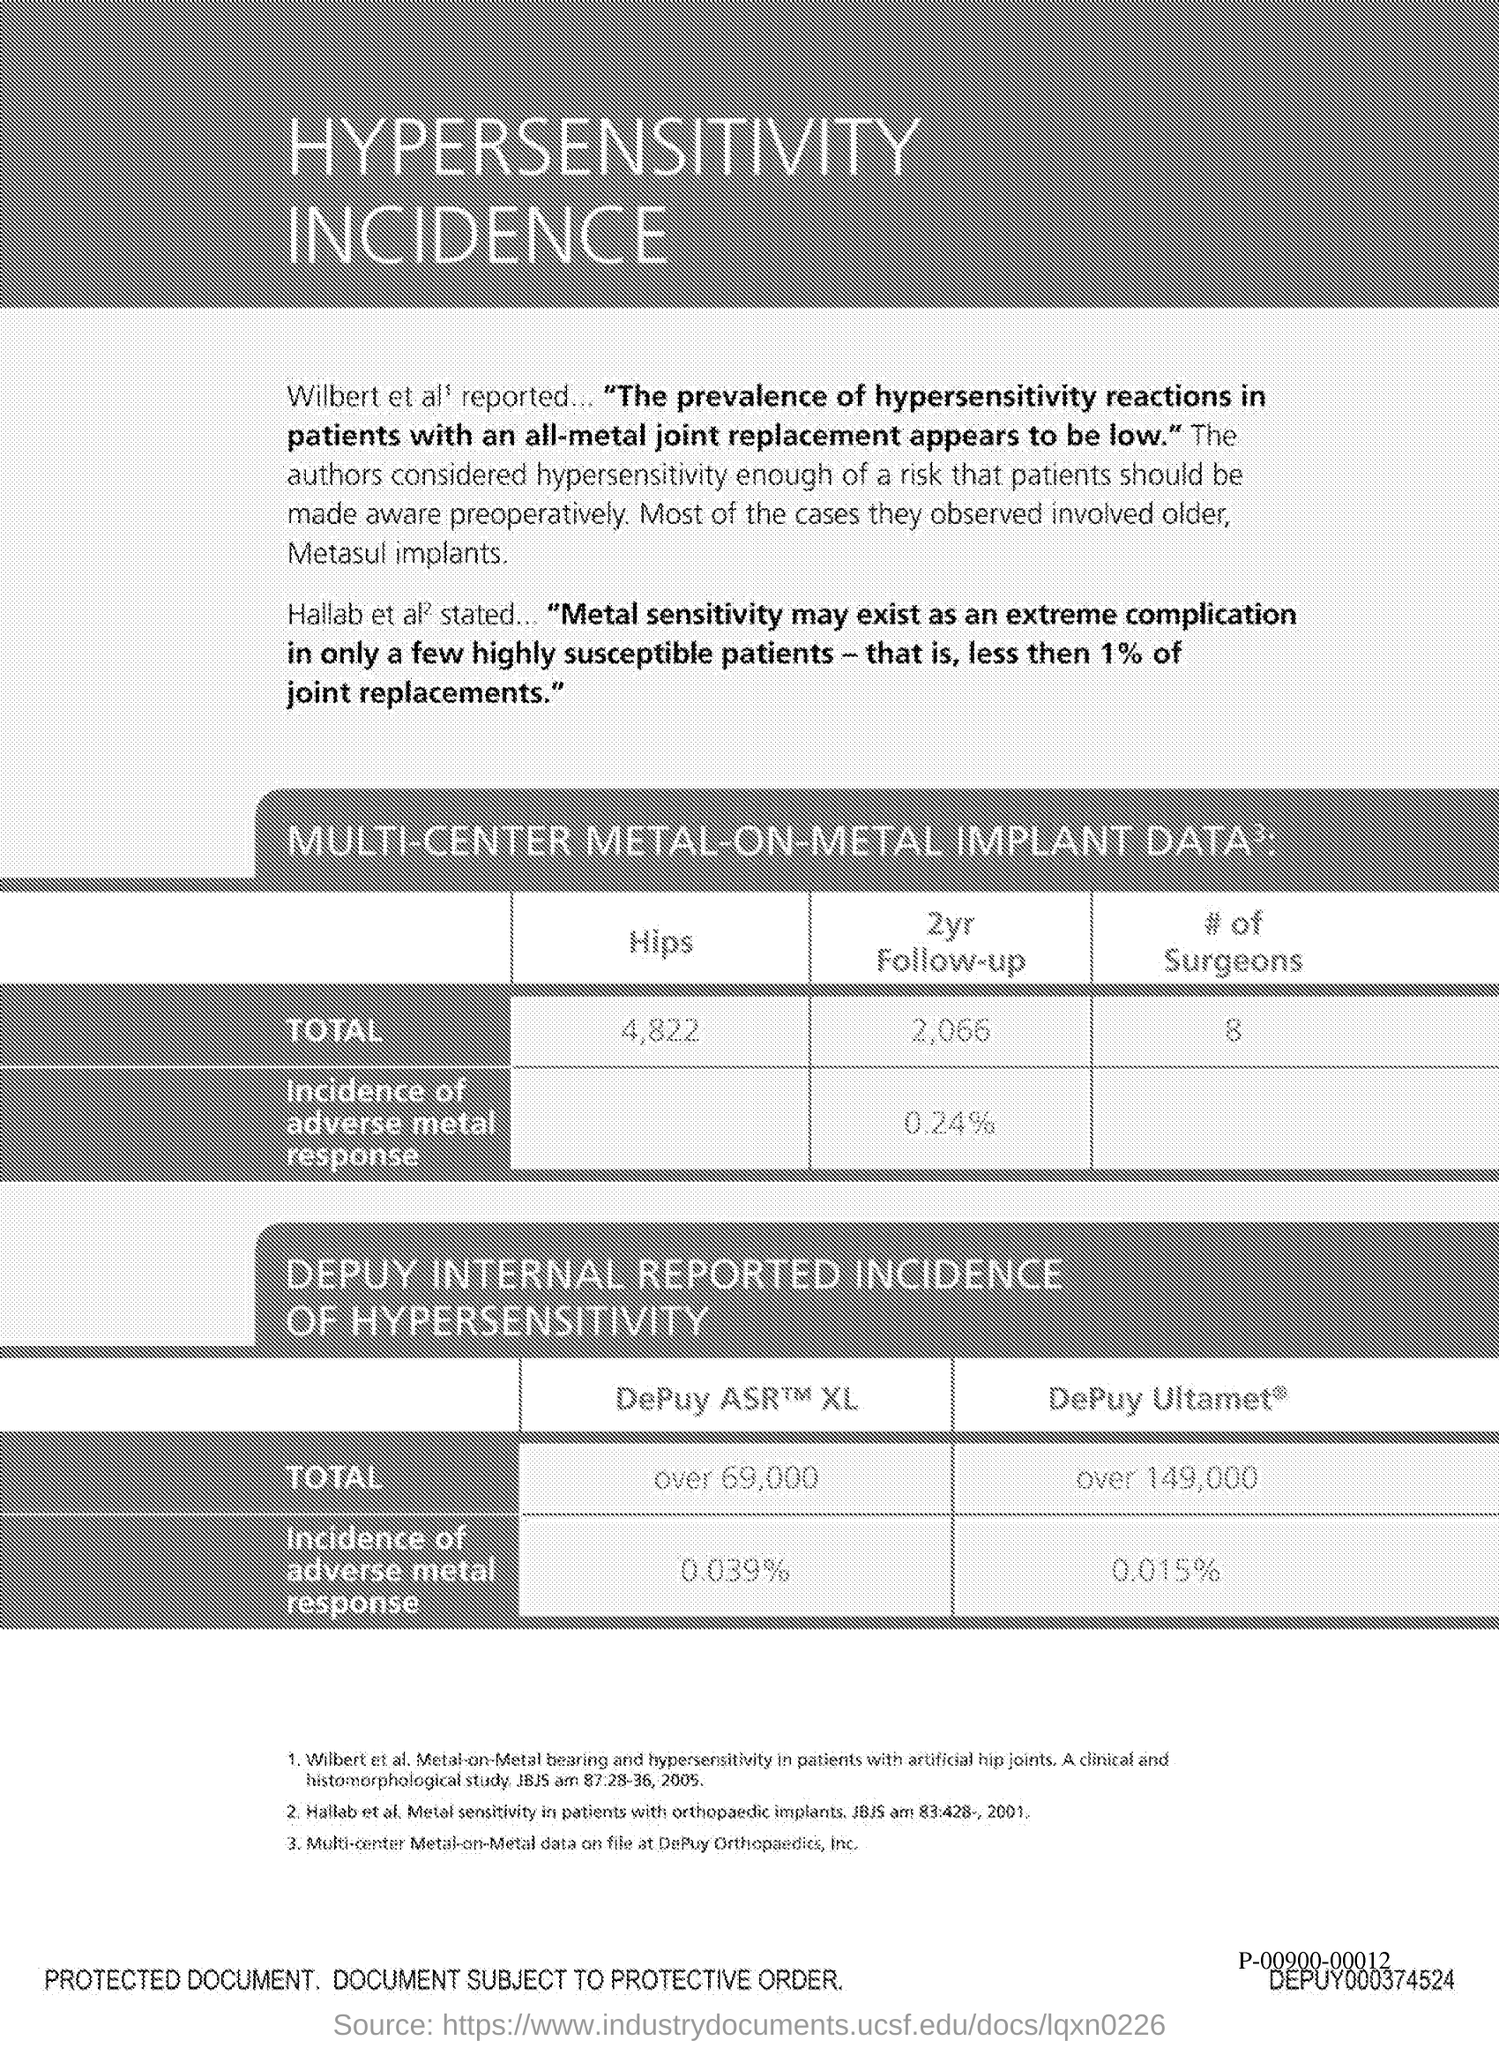What is the title of the document?
Your answer should be very brief. HYPERSENSITIVITY INCIDENCE. What is the total number of hips?
Your response must be concise. 4,822. 